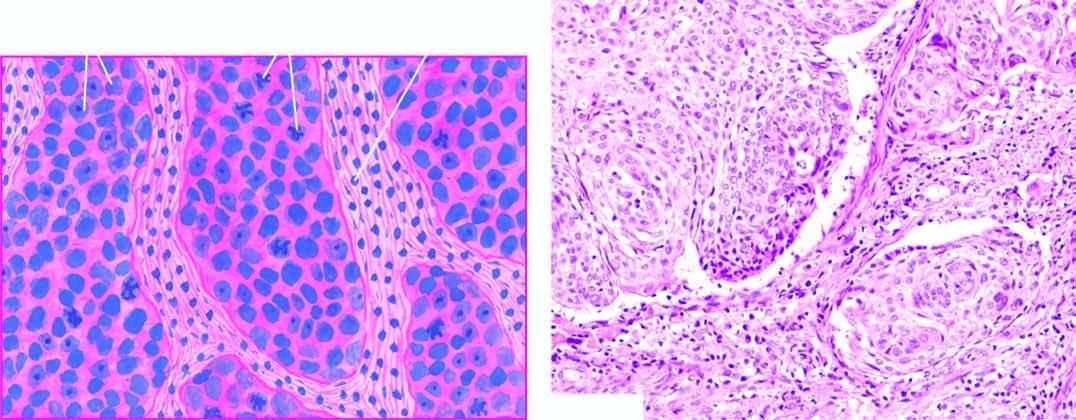s the photomicrograph on right epidermoid carcinoma showing the pattern of a moderatelydifferentiated non-keratinising large cell carcinoma?
Answer the question using a single word or phrase. No 